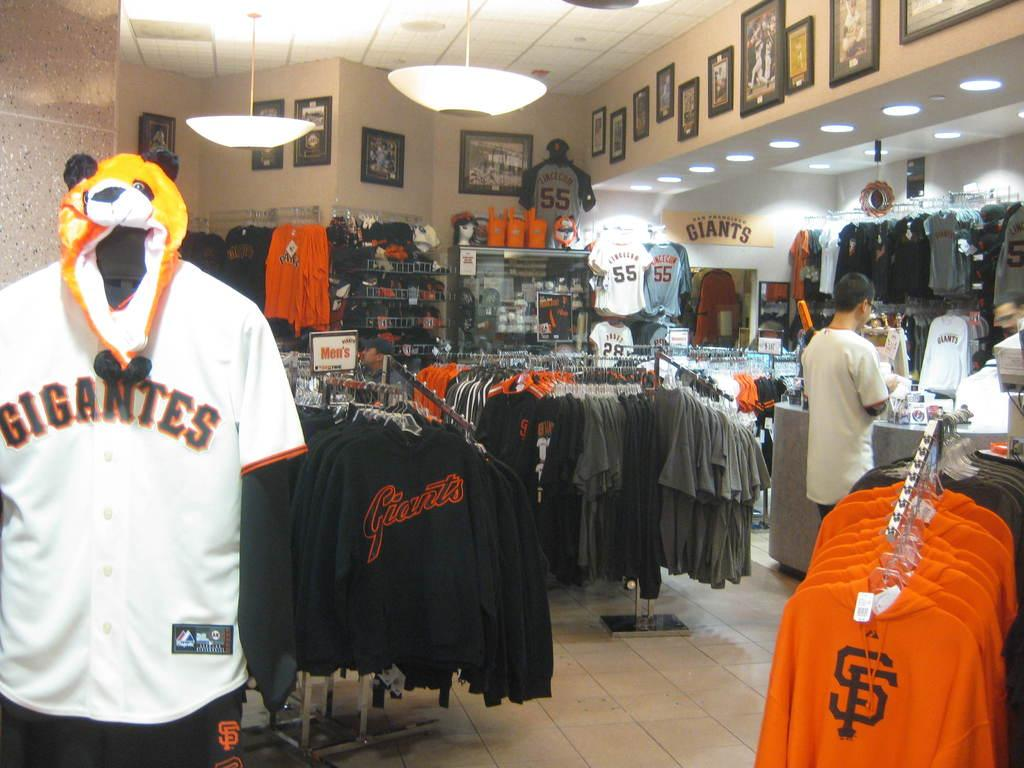<image>
Offer a succinct explanation of the picture presented. A man is at the register, in a store that that sells apparel and accessories for the San Francisco Gigantes. 